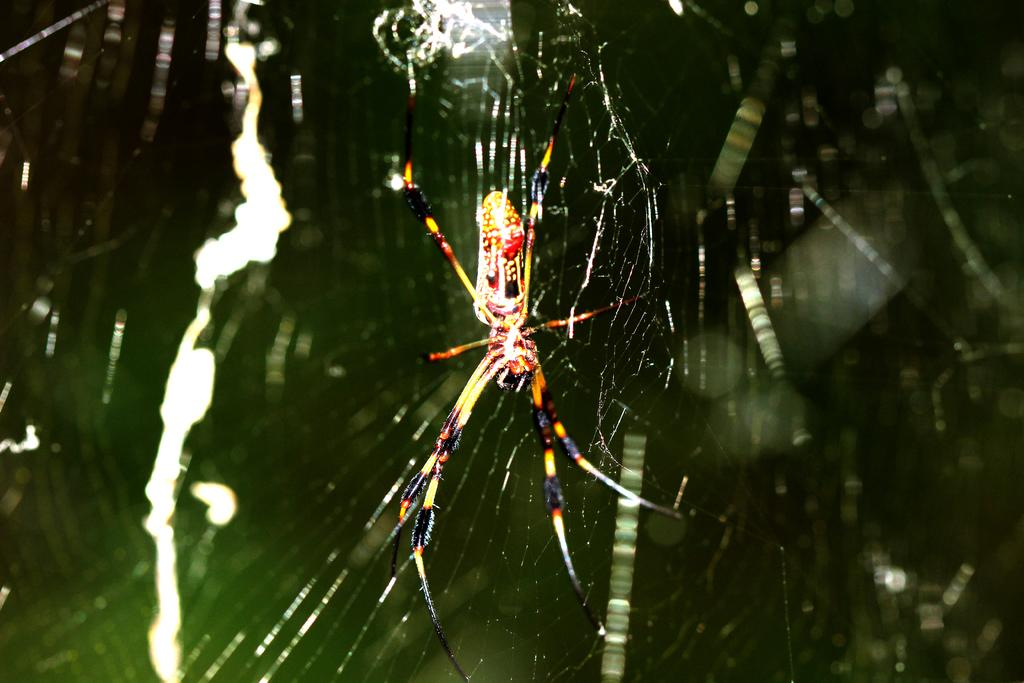What is the main subject of the image? The main subject of the image is a spider. Does the spider have any specific features or characteristics? Yes, the spider has a web. Can you describe the background of the image? The background of the image is blurred. How many holes can be seen in the spider's web in the image? There are no holes visible in the spider's web in the image. What type of coil is present in the image? There is no coil present in the image. 